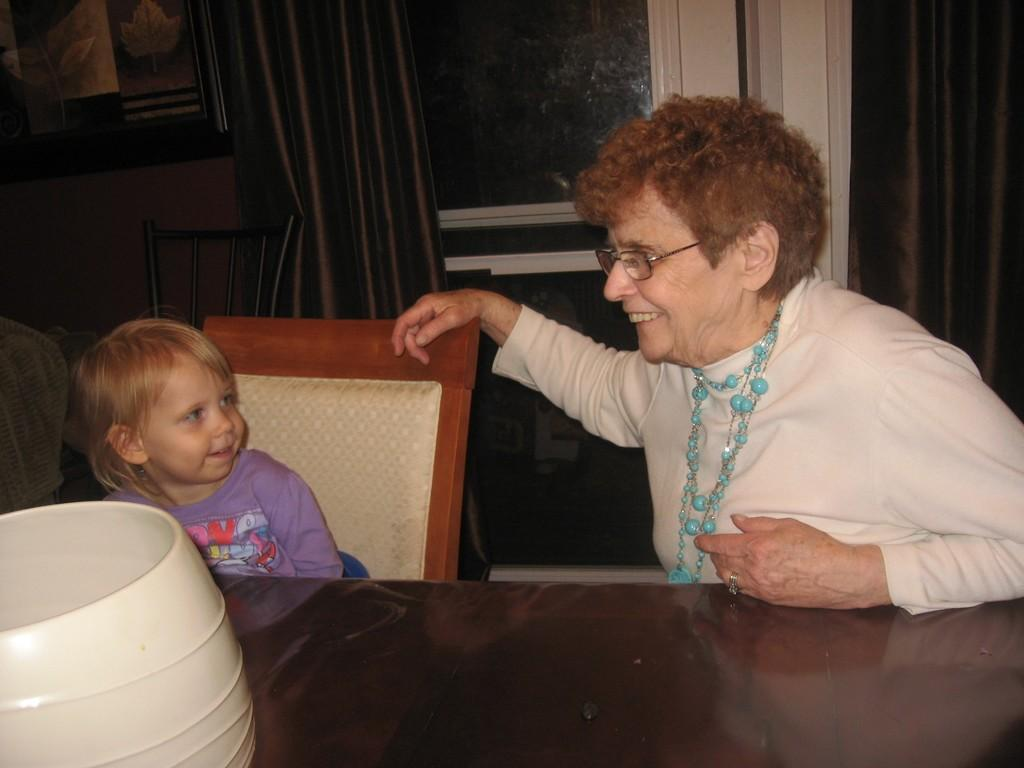Who is present in the image? There is a woman and a kid in the image. What are they doing in the image? Both the woman and the kid are sitting on chairs. What is in front of them? There is a table in front of them. What can be found on the table? There are bowls on the table. What is visible in the background of the image? There is a door in the background of the image, and a curtain is associated with the door. What type of cork can be seen on the floor in the image? There is no cork visible on the floor in the image. What kind of border is present around the door in the image? There is no border mentioned or visible around the door in the image. 